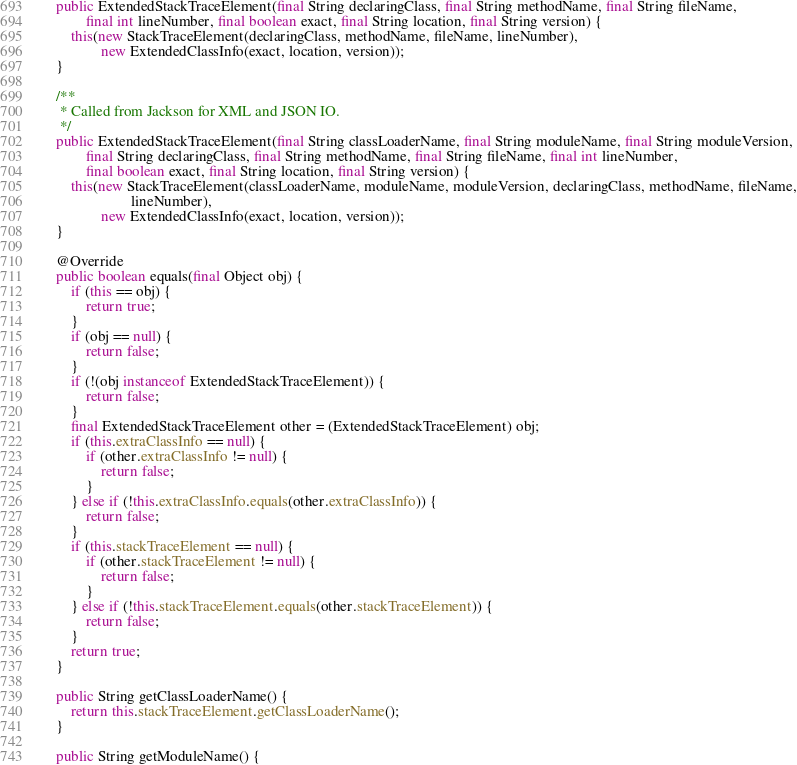<code> <loc_0><loc_0><loc_500><loc_500><_Java_>    public ExtendedStackTraceElement(final String declaringClass, final String methodName, final String fileName,
            final int lineNumber, final boolean exact, final String location, final String version) {
        this(new StackTraceElement(declaringClass, methodName, fileName, lineNumber),
                new ExtendedClassInfo(exact, location, version));
    }

    /**
     * Called from Jackson for XML and JSON IO.
     */
    public ExtendedStackTraceElement(final String classLoaderName, final String moduleName, final String moduleVersion,
            final String declaringClass, final String methodName, final String fileName, final int lineNumber,
            final boolean exact, final String location, final String version) {
        this(new StackTraceElement(classLoaderName, moduleName, moduleVersion, declaringClass, methodName, fileName,
                        lineNumber),
                new ExtendedClassInfo(exact, location, version));
    }

    @Override
    public boolean equals(final Object obj) {
        if (this == obj) {
            return true;
        }
        if (obj == null) {
            return false;
        }
        if (!(obj instanceof ExtendedStackTraceElement)) {
            return false;
        }
        final ExtendedStackTraceElement other = (ExtendedStackTraceElement) obj;
        if (this.extraClassInfo == null) {
            if (other.extraClassInfo != null) {
                return false;
            }
        } else if (!this.extraClassInfo.equals(other.extraClassInfo)) {
            return false;
        }
        if (this.stackTraceElement == null) {
            if (other.stackTraceElement != null) {
                return false;
            }
        } else if (!this.stackTraceElement.equals(other.stackTraceElement)) {
            return false;
        }
        return true;
    }

    public String getClassLoaderName() {
        return this.stackTraceElement.getClassLoaderName();
    }

    public String getModuleName() {</code> 